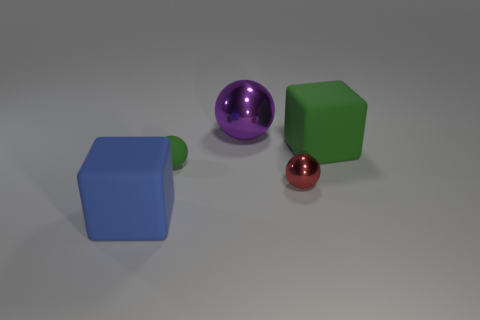There is a matte ball to the left of the big green rubber thing; is it the same color as the matte object that is behind the green matte ball?
Keep it short and to the point. Yes. What is the shape of the large matte object to the right of the block to the left of the thing right of the red object?
Offer a terse response. Cube. What is the shape of the large object that is both in front of the large shiny thing and to the right of the green matte sphere?
Your answer should be very brief. Cube. How many big things are in front of the metal ball that is in front of the big cube to the right of the big blue matte block?
Ensure brevity in your answer.  1. The rubber object that is the same shape as the purple metallic object is what size?
Give a very brief answer. Small. Is the material of the large thing that is on the left side of the purple metallic sphere the same as the red thing?
Provide a succinct answer. No. There is another matte thing that is the same shape as the blue thing; what color is it?
Make the answer very short. Green. How many other objects are the same color as the small metallic thing?
Keep it short and to the point. 0. Does the large rubber object that is on the right side of the blue matte block have the same shape as the green thing to the left of the green matte block?
Your response must be concise. No. What number of balls are either red objects or matte things?
Keep it short and to the point. 2. 